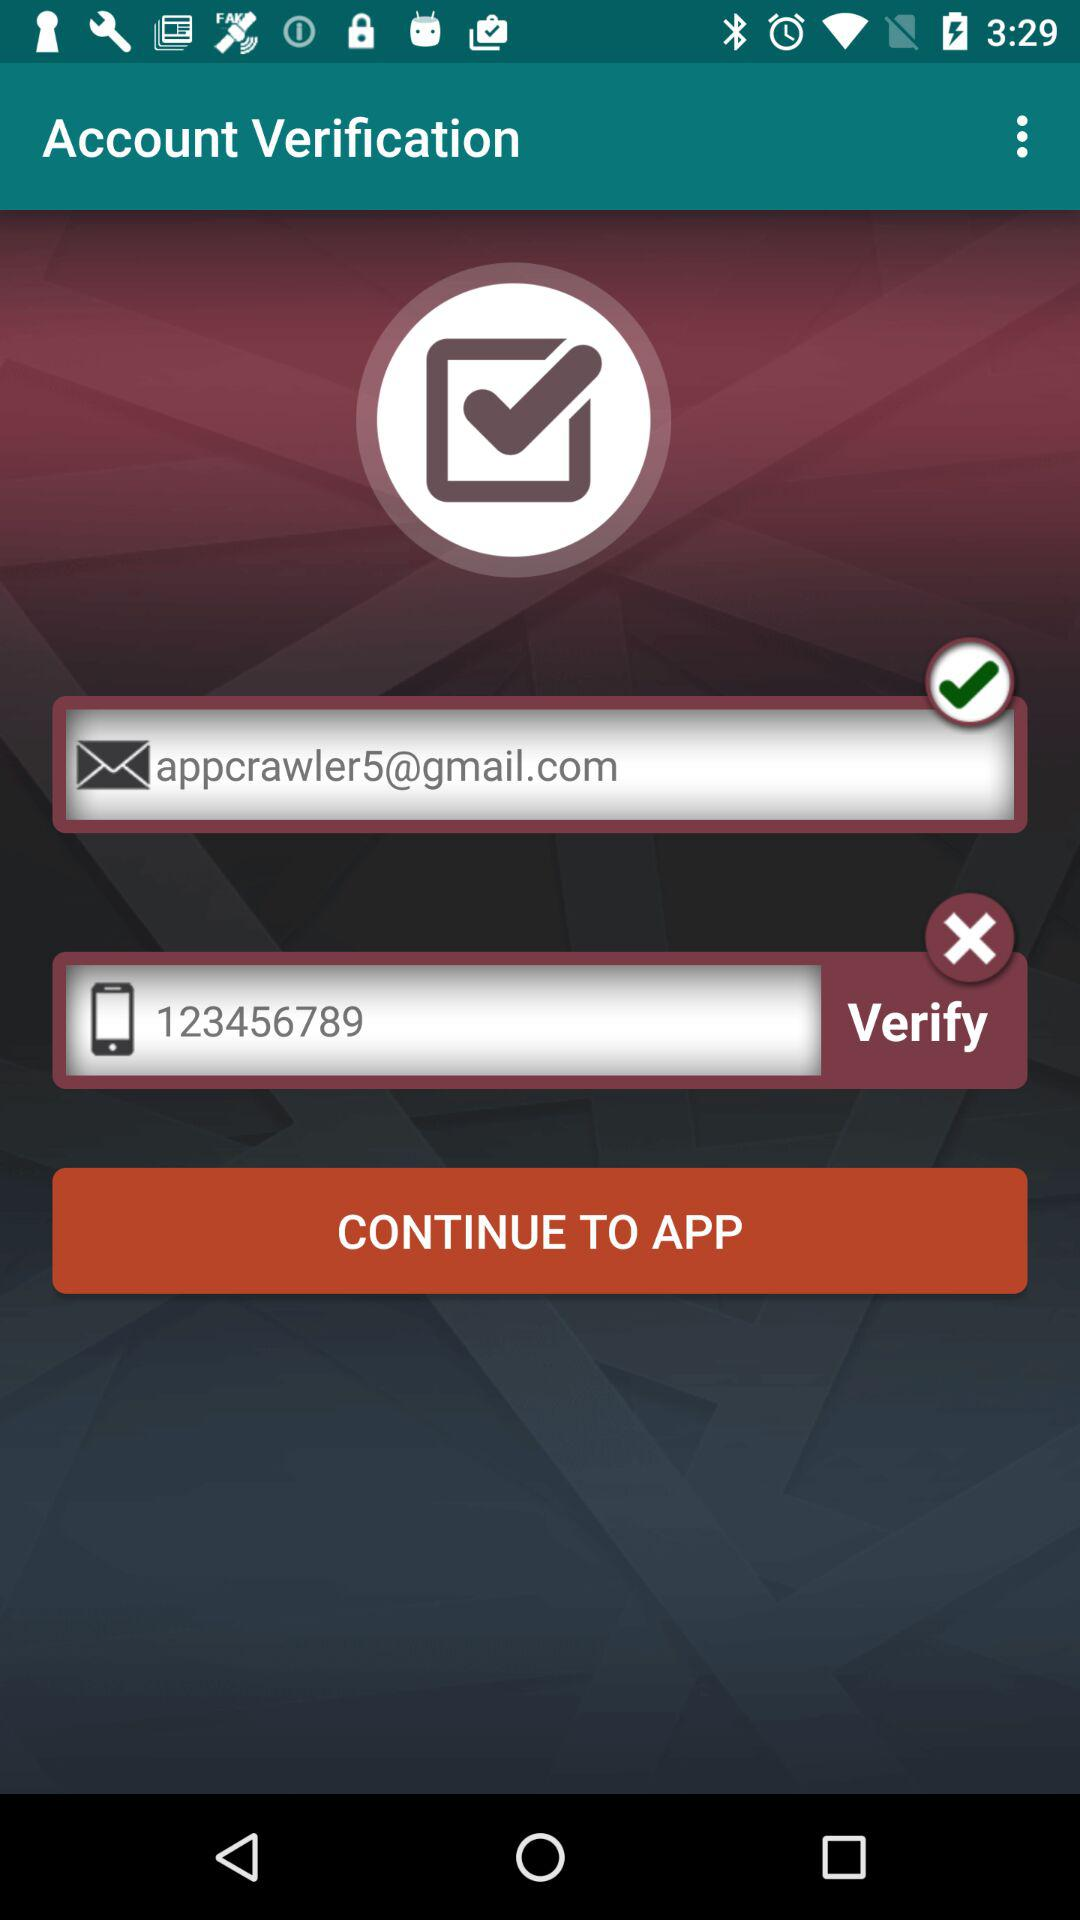What's the Google mail address? The Google mail address is appcrawler5@gmail.com. 